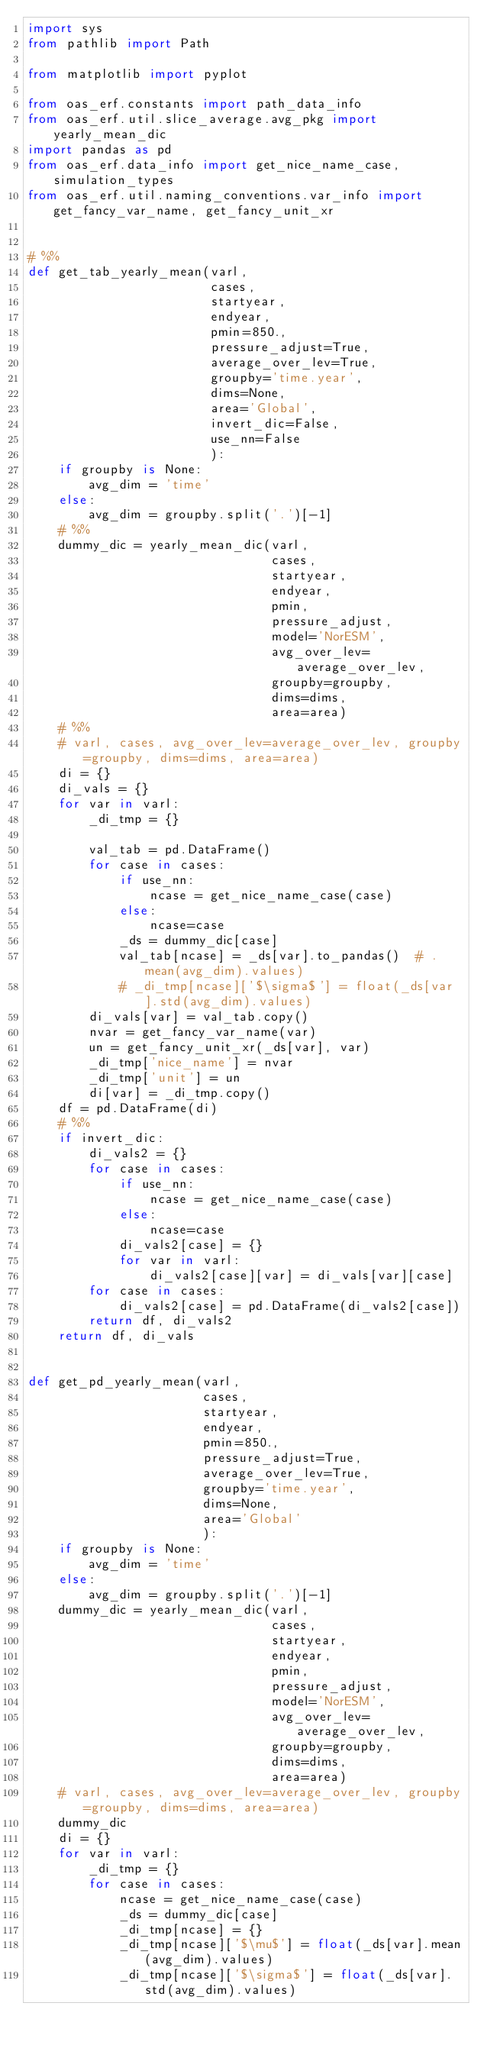Convert code to text. <code><loc_0><loc_0><loc_500><loc_500><_Python_>import sys
from pathlib import Path

from matplotlib import pyplot

from oas_erf.constants import path_data_info
from oas_erf.util.slice_average.avg_pkg import yearly_mean_dic
import pandas as pd
from oas_erf.data_info import get_nice_name_case, simulation_types
from oas_erf.util.naming_conventions.var_info import get_fancy_var_name, get_fancy_unit_xr


# %%
def get_tab_yearly_mean(varl,
                        cases,
                        startyear,
                        endyear,
                        pmin=850.,
                        pressure_adjust=True,
                        average_over_lev=True,
                        groupby='time.year',
                        dims=None,
                        area='Global',
                        invert_dic=False,
                        use_nn=False
                        ):
    if groupby is None:
        avg_dim = 'time'
    else:
        avg_dim = groupby.split('.')[-1]
    # %%
    dummy_dic = yearly_mean_dic(varl,
                                cases,
                                startyear,
                                endyear,
                                pmin,
                                pressure_adjust,
                                model='NorESM',
                                avg_over_lev=average_over_lev,
                                groupby=groupby,
                                dims=dims,
                                area=area)
    # %%
    # varl, cases, avg_over_lev=average_over_lev, groupby=groupby, dims=dims, area=area)
    di = {}
    di_vals = {}
    for var in varl:
        _di_tmp = {}

        val_tab = pd.DataFrame()
        for case in cases:
            if use_nn:
                ncase = get_nice_name_case(case)
            else:
                ncase=case
            _ds = dummy_dic[case]
            val_tab[ncase] = _ds[var].to_pandas()  # .mean(avg_dim).values)
            # _di_tmp[ncase]['$\sigma$'] = float(_ds[var].std(avg_dim).values)
        di_vals[var] = val_tab.copy()
        nvar = get_fancy_var_name(var)
        un = get_fancy_unit_xr(_ds[var], var)
        _di_tmp['nice_name'] = nvar
        _di_tmp['unit'] = un
        di[var] = _di_tmp.copy()
    df = pd.DataFrame(di)
    # %%
    if invert_dic:
        di_vals2 = {}
        for case in cases:
            if use_nn:
                ncase = get_nice_name_case(case)
            else:
                ncase=case
            di_vals2[case] = {}
            for var in varl:
                di_vals2[case][var] = di_vals[var][case]
        for case in cases:
            di_vals2[case] = pd.DataFrame(di_vals2[case])
        return df, di_vals2
    return df, di_vals


def get_pd_yearly_mean(varl,
                       cases,
                       startyear,
                       endyear,
                       pmin=850.,
                       pressure_adjust=True,
                       average_over_lev=True,
                       groupby='time.year',
                       dims=None,
                       area='Global'
                       ):
    if groupby is None:
        avg_dim = 'time'
    else:
        avg_dim = groupby.split('.')[-1]
    dummy_dic = yearly_mean_dic(varl,
                                cases,
                                startyear,
                                endyear,
                                pmin,
                                pressure_adjust,
                                model='NorESM',
                                avg_over_lev=average_over_lev,
                                groupby=groupby,
                                dims=dims,
                                area=area)
    # varl, cases, avg_over_lev=average_over_lev, groupby=groupby, dims=dims, area=area)
    dummy_dic
    di = {}
    for var in varl:
        _di_tmp = {}
        for case in cases:
            ncase = get_nice_name_case(case)
            _ds = dummy_dic[case]
            _di_tmp[ncase] = {}
            _di_tmp[ncase]['$\mu$'] = float(_ds[var].mean(avg_dim).values)
            _di_tmp[ncase]['$\sigma$'] = float(_ds[var].std(avg_dim).values)</code> 